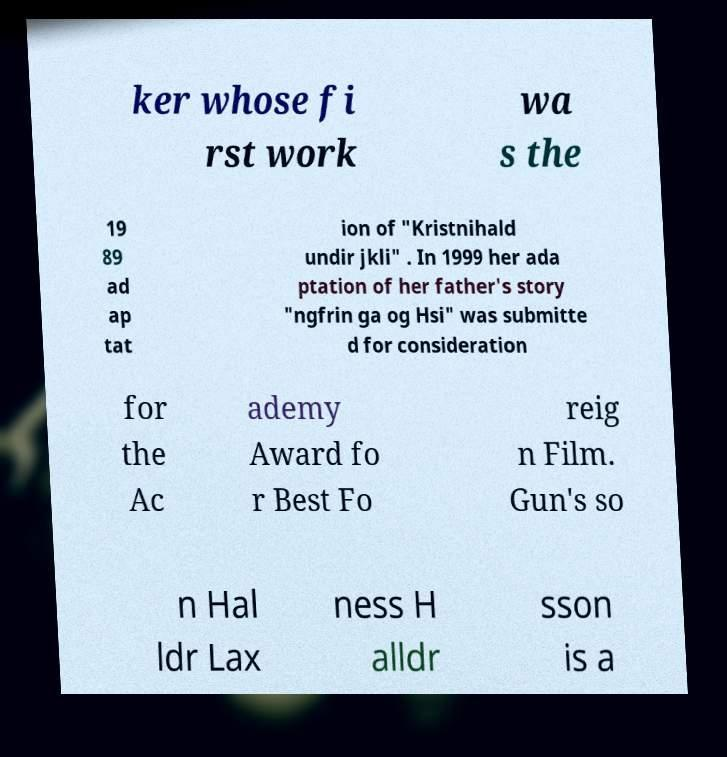Can you accurately transcribe the text from the provided image for me? ker whose fi rst work wa s the 19 89 ad ap tat ion of "Kristnihald undir jkli" . In 1999 her ada ptation of her father's story "ngfrin ga og Hsi" was submitte d for consideration for the Ac ademy Award fo r Best Fo reig n Film. Gun's so n Hal ldr Lax ness H alldr sson is a 